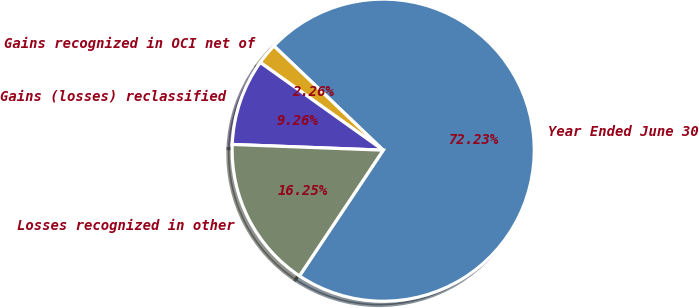<chart> <loc_0><loc_0><loc_500><loc_500><pie_chart><fcel>Year Ended June 30<fcel>Gains recognized in OCI net of<fcel>Gains (losses) reclassified<fcel>Losses recognized in other<nl><fcel>72.23%<fcel>2.26%<fcel>9.26%<fcel>16.25%<nl></chart> 